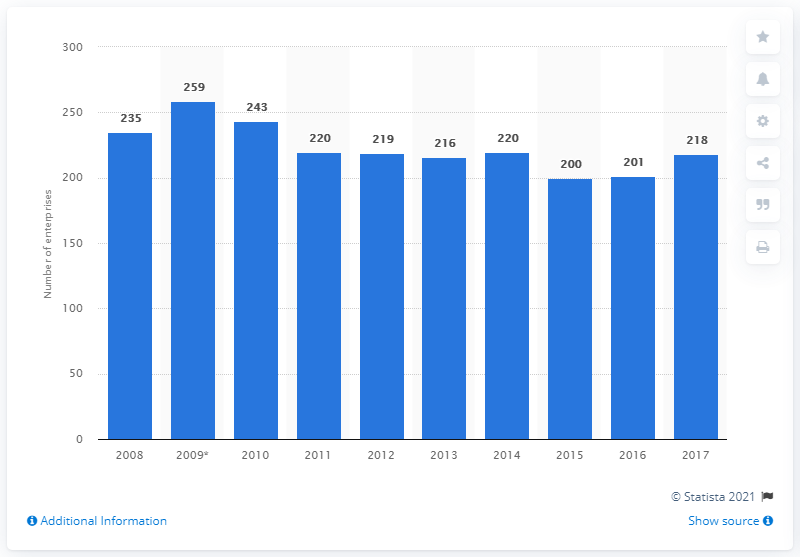Highlight a few significant elements in this photo. In 2017, there were 218 enterprises operating in Romania's cocoa, chocolate, and sugar confectionery industry. 